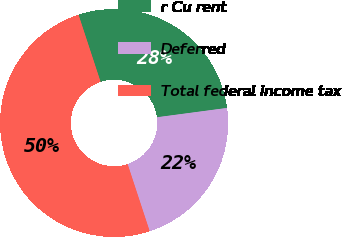Convert chart to OTSL. <chart><loc_0><loc_0><loc_500><loc_500><pie_chart><fcel>r Cu rent<fcel>Deferred<fcel>Total federal income tax<nl><fcel>27.95%<fcel>22.05%<fcel>50.0%<nl></chart> 